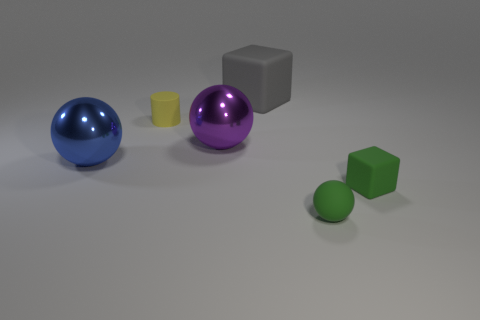Add 4 tiny purple rubber spheres. How many objects exist? 10 Subtract all cubes. How many objects are left? 4 Subtract 0 red cylinders. How many objects are left? 6 Subtract all large purple shiny things. Subtract all large cyan rubber spheres. How many objects are left? 5 Add 3 metallic objects. How many metallic objects are left? 5 Add 6 small rubber spheres. How many small rubber spheres exist? 7 